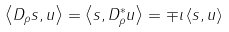Convert formula to latex. <formula><loc_0><loc_0><loc_500><loc_500>\, \left \langle D _ { \rho } s , u \right \rangle = \left \langle s , D _ { \rho } ^ { \ast } u \right \rangle = \mp \iota \left \langle s , u \right \rangle</formula> 